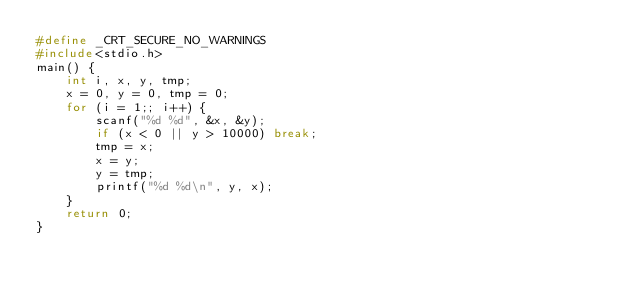<code> <loc_0><loc_0><loc_500><loc_500><_C_>#define _CRT_SECURE_NO_WARNINGS 
#include<stdio.h>
main() {
	int i, x, y, tmp;
	x = 0, y = 0, tmp = 0;
	for (i = 1;; i++) {
		scanf("%d %d", &x, &y);
		if (x < 0 || y > 10000) break;
		tmp = x;
		x = y;
		y = tmp;
		printf("%d %d\n", y, x);
	}
	return 0;
}
</code> 